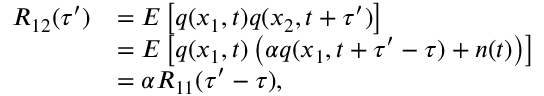<formula> <loc_0><loc_0><loc_500><loc_500>\begin{array} { r l } { R _ { 1 2 } ( \tau ^ { \prime } ) } & { = E \left [ q ( x _ { 1 } , t ) q ( x _ { 2 } , t + \tau ^ { \prime } ) \right ] } \\ & { = E \left [ q ( x _ { 1 } , t ) \left ( \alpha q ( x _ { 1 } , t + \tau ^ { \prime } - \tau ) + n ( t ) \right ) \right ] } \\ & { = \alpha R _ { 1 1 } ( \tau ^ { \prime } - \tau ) , } \end{array}</formula> 